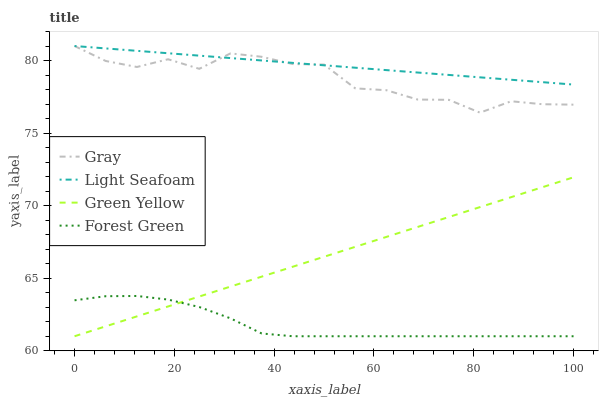Does Green Yellow have the minimum area under the curve?
Answer yes or no. No. Does Green Yellow have the maximum area under the curve?
Answer yes or no. No. Is Light Seafoam the smoothest?
Answer yes or no. No. Is Light Seafoam the roughest?
Answer yes or no. No. Does Light Seafoam have the lowest value?
Answer yes or no. No. Does Green Yellow have the highest value?
Answer yes or no. No. Is Green Yellow less than Light Seafoam?
Answer yes or no. Yes. Is Light Seafoam greater than Forest Green?
Answer yes or no. Yes. Does Green Yellow intersect Light Seafoam?
Answer yes or no. No. 